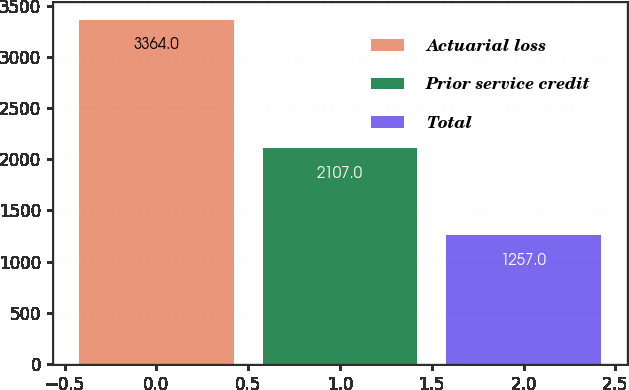Convert chart to OTSL. <chart><loc_0><loc_0><loc_500><loc_500><bar_chart><fcel>Actuarial loss<fcel>Prior service credit<fcel>Total<nl><fcel>3364<fcel>2107<fcel>1257<nl></chart> 